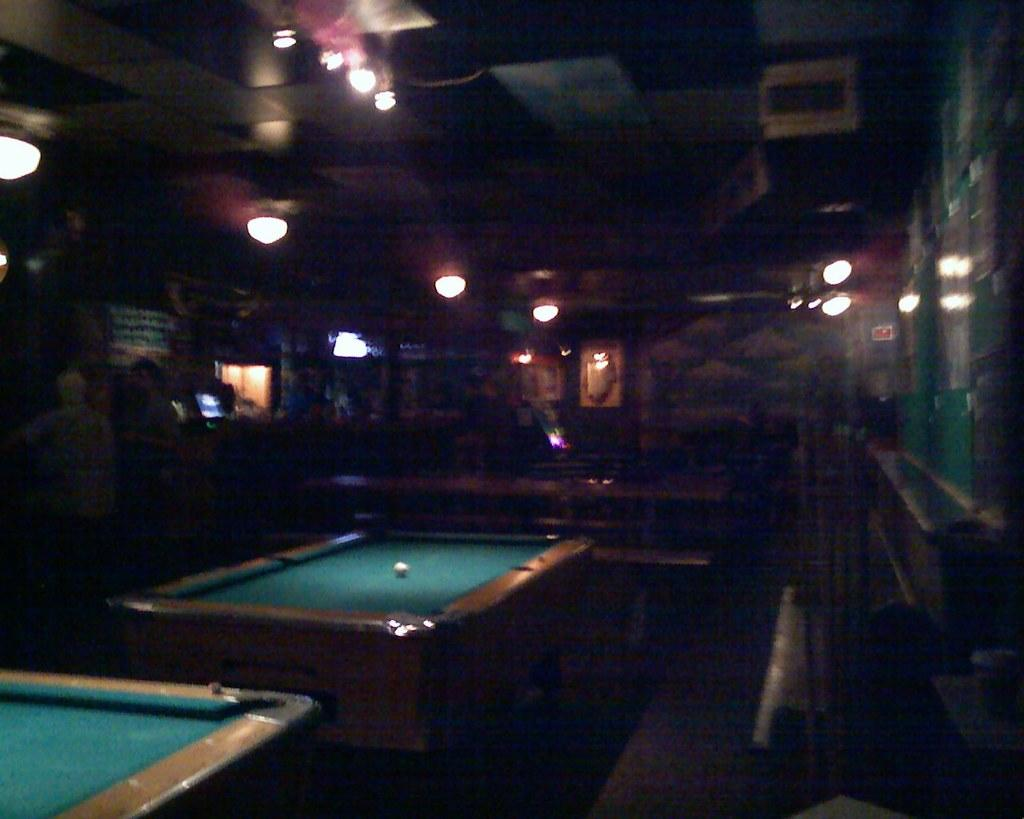What can be seen in the image that provides illumination? There are lights in the image. What type of game or activity is being played in the image? There are two billiards boards in the image, suggesting that billiards is being played. What is the price of the achiever's basket in the image? There is no achiever or basket present in the image. What type of fruit can be seen in the achiever's basket in the image? There is no achiever or basket present in the image. 